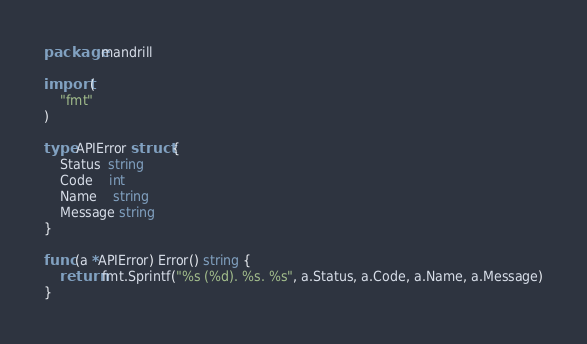<code> <loc_0><loc_0><loc_500><loc_500><_Go_>package mandrill

import (
	"fmt"
)

type APIError struct {
	Status  string
	Code    int
	Name    string
	Message string
}

func (a *APIError) Error() string {
	return fmt.Sprintf("%s (%d). %s. %s", a.Status, a.Code, a.Name, a.Message)
}
</code> 